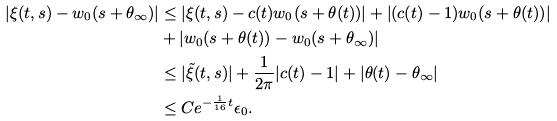Convert formula to latex. <formula><loc_0><loc_0><loc_500><loc_500>\left | \xi ( t , s ) - w _ { 0 } ( s + \theta _ { \infty } ) \right | & \leq \left | \xi ( t , s ) - c ( t ) w _ { 0 } ( s + \theta ( t ) ) \right | + \left | ( c ( t ) - 1 ) w _ { 0 } ( s + \theta ( t ) ) \right | \\ & + \left | w _ { 0 } ( s + \theta ( t ) ) - w _ { 0 } ( s + \theta _ { \infty } ) \right | \\ & \leq | \tilde { \xi } ( t , s ) | + \frac { 1 } { 2 \pi } | c ( t ) - 1 | + | \theta ( t ) - \theta _ { \infty } | \\ & \leq C e ^ { - \frac { 1 } { 1 6 } t } \epsilon _ { 0 } .</formula> 